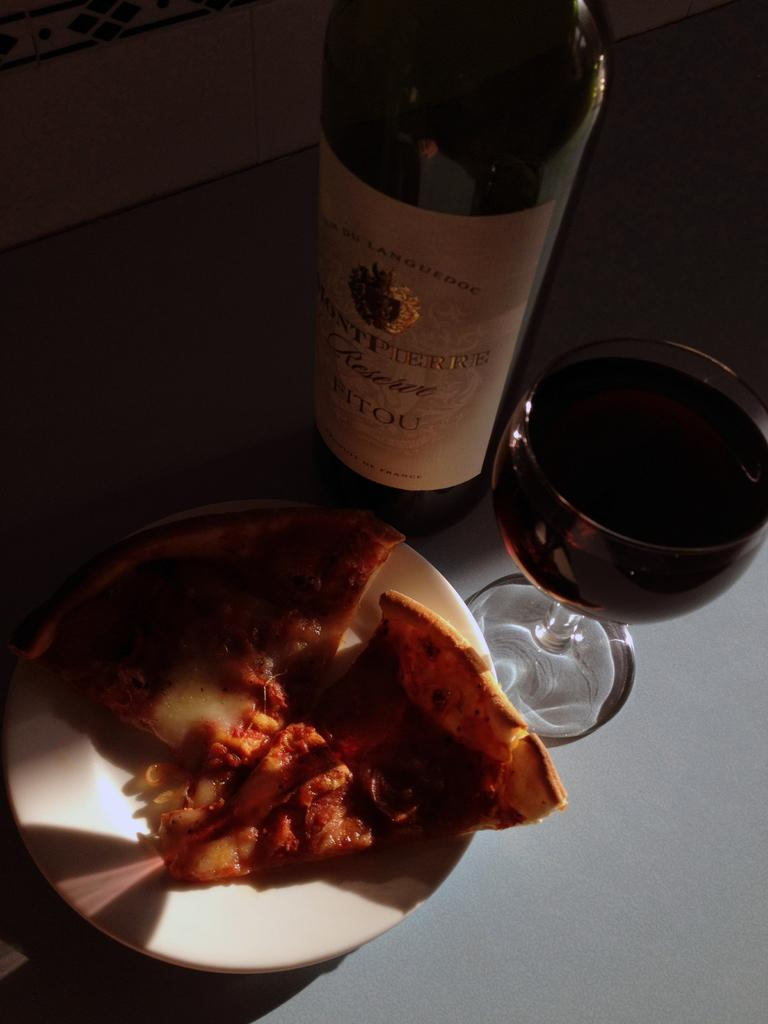What is one of the objects placed on the floor in the image? There is a bottle in the image. What is another object placed on the floor in the image? There is a glass with a drink in the image. What is the third object placed on the floor in the image? There is a plate with food in the image. What language is spoken by the eyes in the image? There are no eyes present in the image, so it is not possible to determine what language they might speak. 